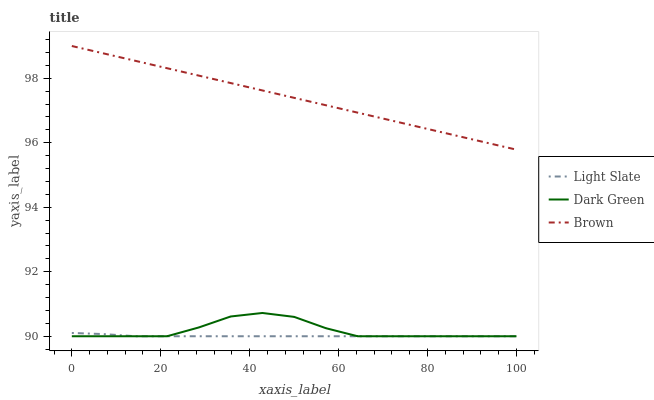Does Light Slate have the minimum area under the curve?
Answer yes or no. Yes. Does Brown have the maximum area under the curve?
Answer yes or no. Yes. Does Dark Green have the minimum area under the curve?
Answer yes or no. No. Does Dark Green have the maximum area under the curve?
Answer yes or no. No. Is Brown the smoothest?
Answer yes or no. Yes. Is Dark Green the roughest?
Answer yes or no. Yes. Is Dark Green the smoothest?
Answer yes or no. No. Is Brown the roughest?
Answer yes or no. No. Does Light Slate have the lowest value?
Answer yes or no. Yes. Does Brown have the lowest value?
Answer yes or no. No. Does Brown have the highest value?
Answer yes or no. Yes. Does Dark Green have the highest value?
Answer yes or no. No. Is Dark Green less than Brown?
Answer yes or no. Yes. Is Brown greater than Dark Green?
Answer yes or no. Yes. Does Dark Green intersect Light Slate?
Answer yes or no. Yes. Is Dark Green less than Light Slate?
Answer yes or no. No. Is Dark Green greater than Light Slate?
Answer yes or no. No. Does Dark Green intersect Brown?
Answer yes or no. No. 